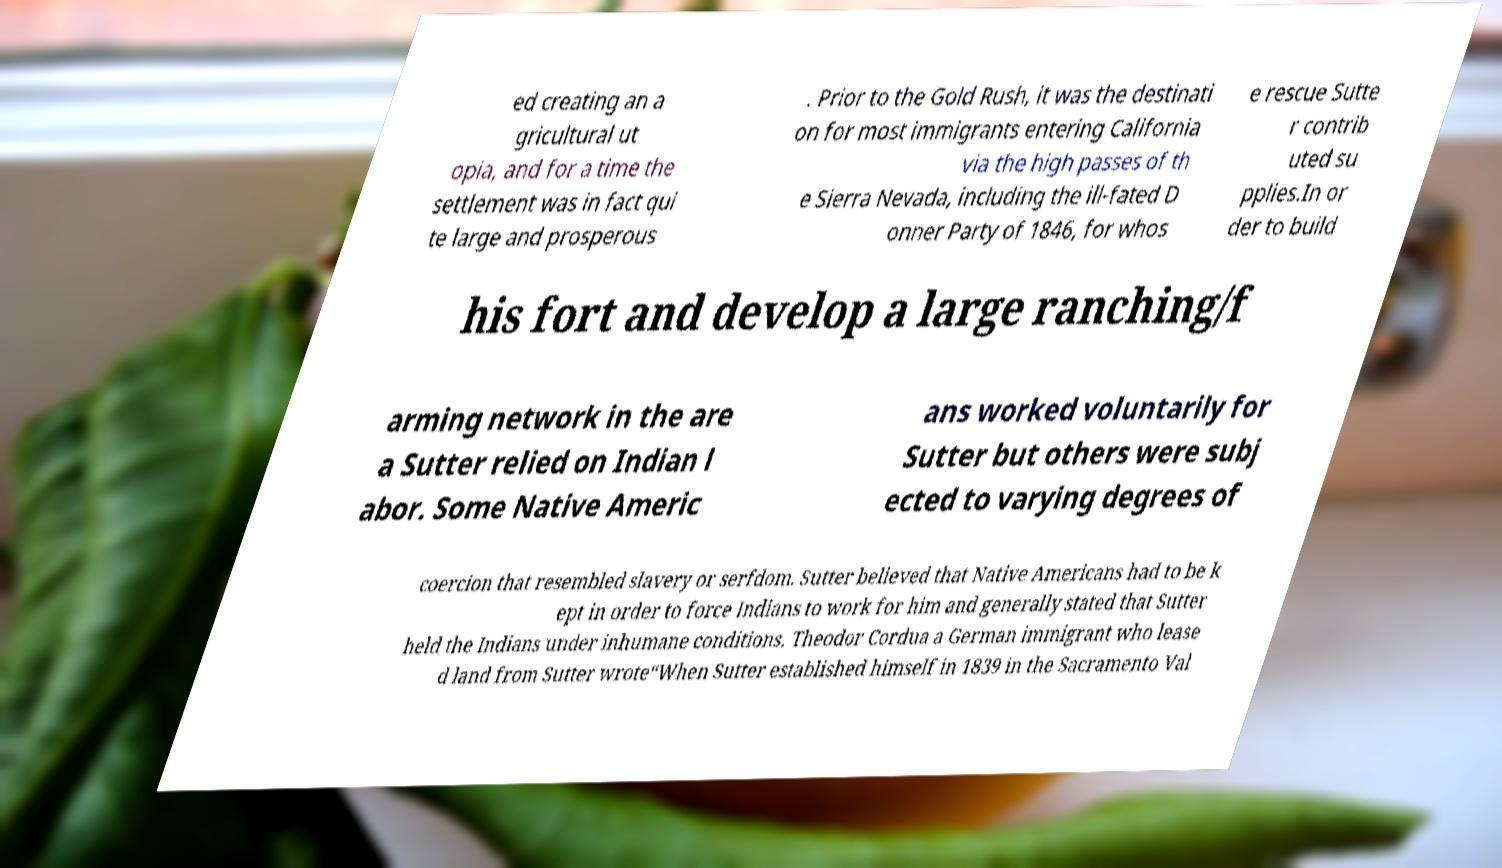Can you read and provide the text displayed in the image?This photo seems to have some interesting text. Can you extract and type it out for me? ed creating an a gricultural ut opia, and for a time the settlement was in fact qui te large and prosperous . Prior to the Gold Rush, it was the destinati on for most immigrants entering California via the high passes of th e Sierra Nevada, including the ill-fated D onner Party of 1846, for whos e rescue Sutte r contrib uted su pplies.In or der to build his fort and develop a large ranching/f arming network in the are a Sutter relied on Indian l abor. Some Native Americ ans worked voluntarily for Sutter but others were subj ected to varying degrees of coercion that resembled slavery or serfdom. Sutter believed that Native Americans had to be k ept in order to force Indians to work for him and generally stated that Sutter held the Indians under inhumane conditions. Theodor Cordua a German immigrant who lease d land from Sutter wrote“When Sutter established himself in 1839 in the Sacramento Val 